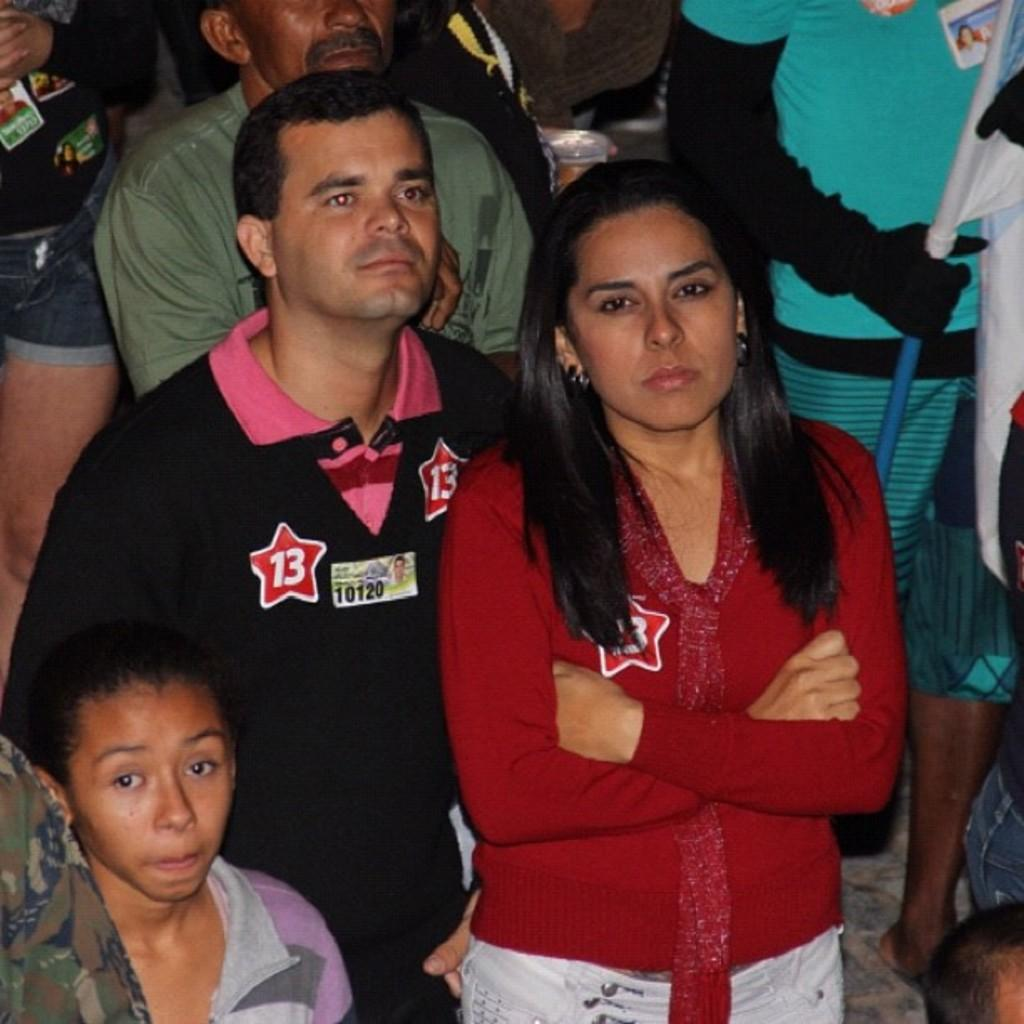How many people are in the image? There is a group of people standing in the image. What is at the bottom of the image? There is a floor at the bottom of the image. Can you describe the person standing on the floor? The person standing on the floor is holding a flag. How many bees can be seen flying through the window in the image? There is no window or bees present in the image. Can you describe the type of help the person holding the flag is providing in the image? The image does not provide any information about the person's actions or intentions, so it is not possible to determine if they are providing help or not. 